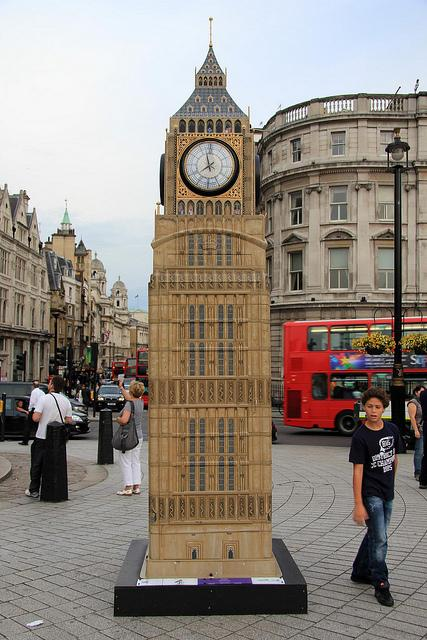What is actually the tallest object in the picture? Please explain your reasoning. buildings. The buildings in the back are the tallest. 